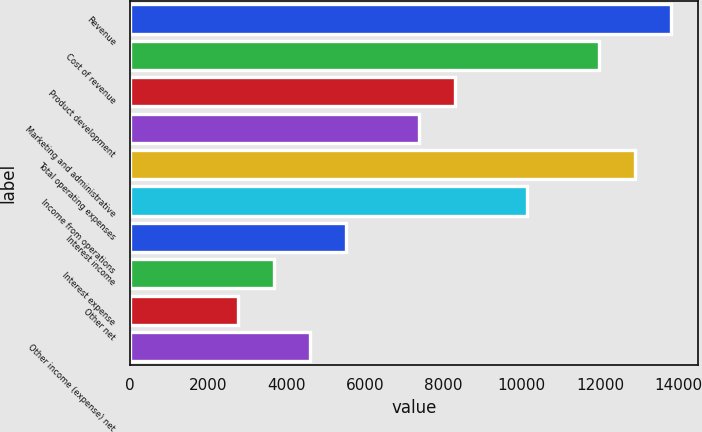<chart> <loc_0><loc_0><loc_500><loc_500><bar_chart><fcel>Revenue<fcel>Cost of revenue<fcel>Product development<fcel>Marketing and administrative<fcel>Total operating expenses<fcel>Income from operations<fcel>Interest income<fcel>Interest expense<fcel>Other net<fcel>Other income (expense) net<nl><fcel>13808.9<fcel>11967.7<fcel>8285.45<fcel>7364.88<fcel>12888.3<fcel>10126.6<fcel>5523.74<fcel>3682.6<fcel>2762.03<fcel>4603.17<nl></chart> 